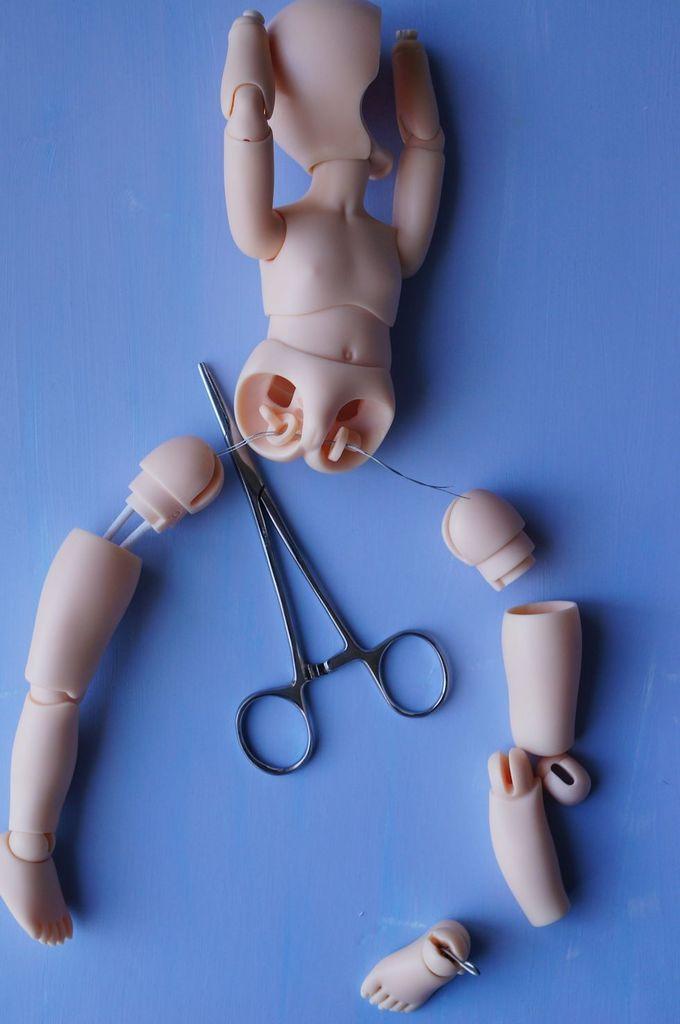Can you describe this image briefly? In this picture, we see the parts of the toy and the scissors. In the background, it is blue in color. 